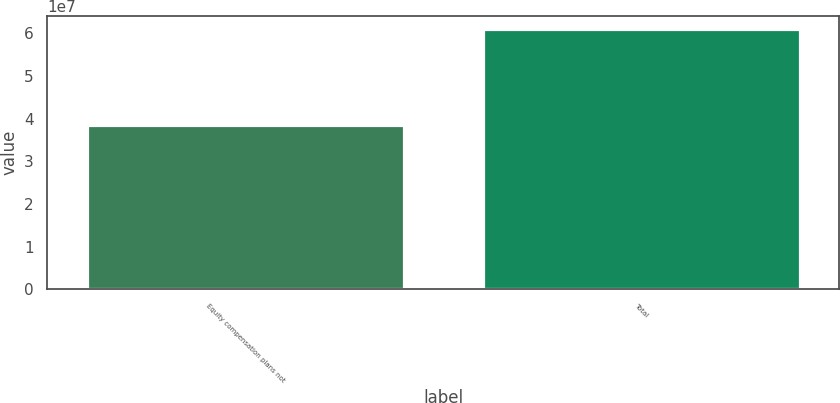<chart> <loc_0><loc_0><loc_500><loc_500><bar_chart><fcel>Equity compensation plans not<fcel>Total<nl><fcel>3.85443e+07<fcel>6.09826e+07<nl></chart> 